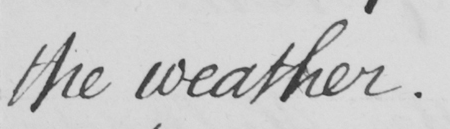Can you tell me what this handwritten text says? the weather. 